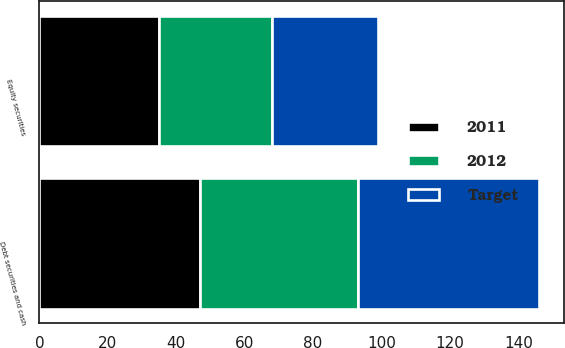<chart> <loc_0><loc_0><loc_500><loc_500><stacked_bar_chart><ecel><fcel>Equity securities<fcel>Debt securities and cash<nl><fcel>2012<fcel>33<fcel>46<nl><fcel>2011<fcel>35<fcel>47<nl><fcel>Target<fcel>31<fcel>53<nl></chart> 